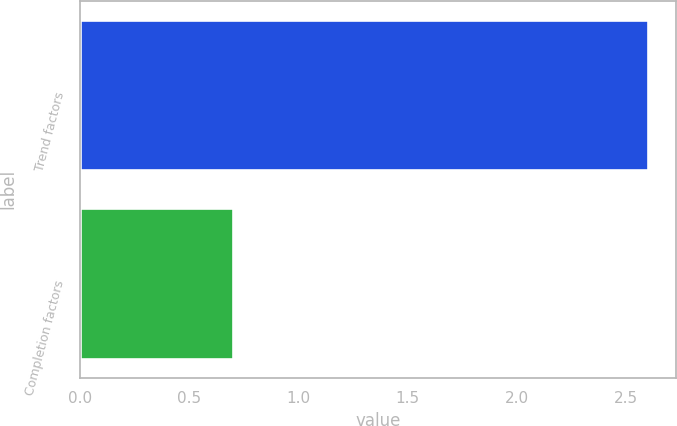<chart> <loc_0><loc_0><loc_500><loc_500><bar_chart><fcel>Trend factors<fcel>Completion factors<nl><fcel>2.6<fcel>0.7<nl></chart> 